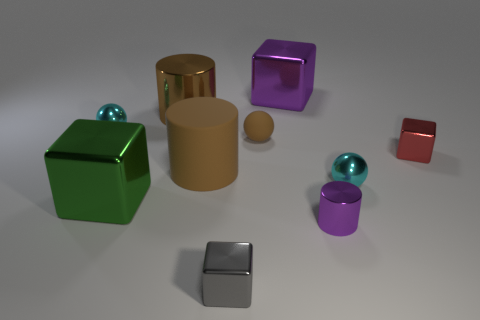What number of other things are the same material as the green block?
Your answer should be very brief. 7. Are there more purple cylinders that are on the left side of the small brown rubber sphere than brown matte objects right of the small purple shiny cylinder?
Provide a succinct answer. No. What number of brown metal objects are left of the large brown metallic object?
Your answer should be compact. 0. Does the small red object have the same material as the cyan ball on the right side of the green thing?
Your answer should be compact. Yes. Is there any other thing that is the same shape as the large purple thing?
Keep it short and to the point. Yes. Is the material of the large purple cube the same as the gray object?
Give a very brief answer. Yes. Is there a cyan sphere behind the tiny cyan object that is right of the brown metallic cylinder?
Provide a succinct answer. Yes. How many objects are both behind the tiny purple metallic object and to the left of the purple metal block?
Your response must be concise. 5. What is the shape of the purple object to the right of the purple metallic cube?
Make the answer very short. Cylinder. How many green metal cubes are the same size as the brown rubber sphere?
Ensure brevity in your answer.  0. 